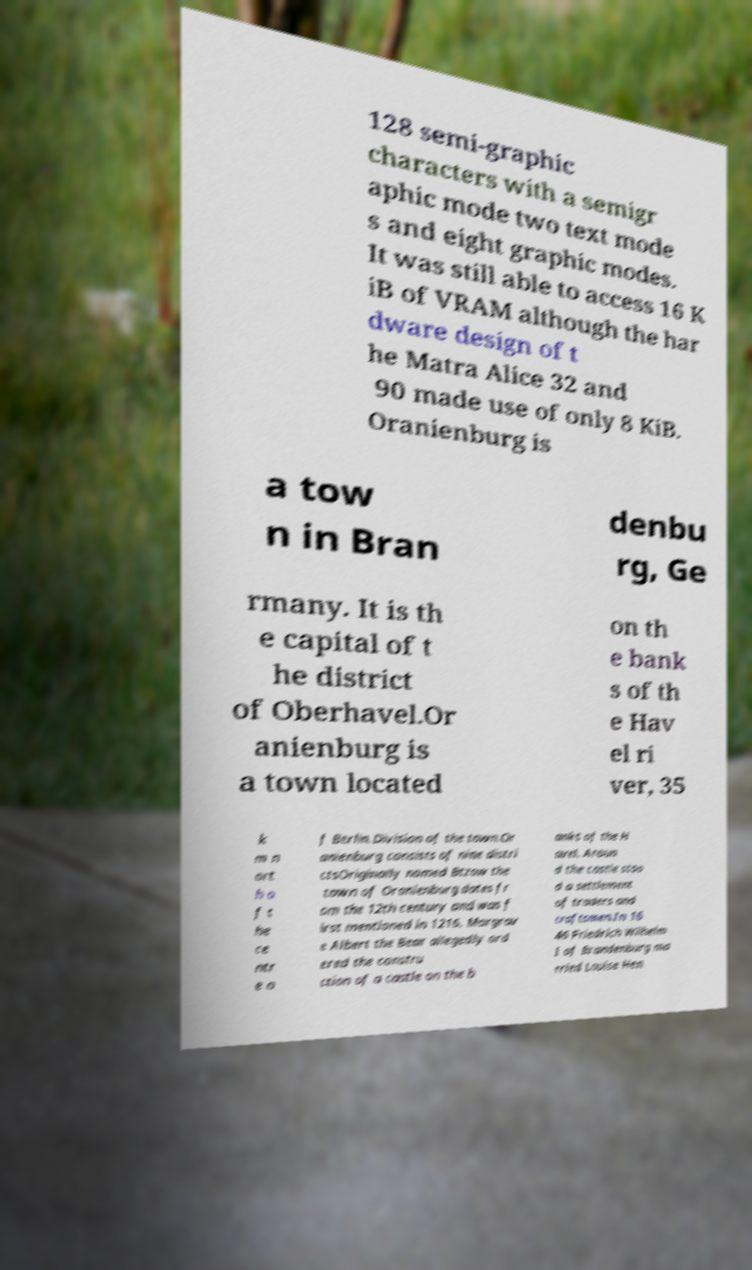Can you read and provide the text displayed in the image?This photo seems to have some interesting text. Can you extract and type it out for me? 128 semi-graphic characters with a semigr aphic mode two text mode s and eight graphic modes. It was still able to access 16 K iB of VRAM although the har dware design of t he Matra Alice 32 and 90 made use of only 8 KiB. Oranienburg is a tow n in Bran denbu rg, Ge rmany. It is th e capital of t he district of Oberhavel.Or anienburg is a town located on th e bank s of th e Hav el ri ver, 35 k m n ort h o f t he ce ntr e o f Berlin.Division of the town.Or anienburg consists of nine distri ctsOriginally named Btzow the town of Oranienburg dates fr om the 12th century and was f irst mentioned in 1216. Margrav e Albert the Bear allegedly ord ered the constru ction of a castle on the b anks of the H avel. Aroun d the castle stoo d a settlement of traders and craftsmen.In 16 46 Friedrich Wilhelm I of Brandenburg ma rried Louise Hen 